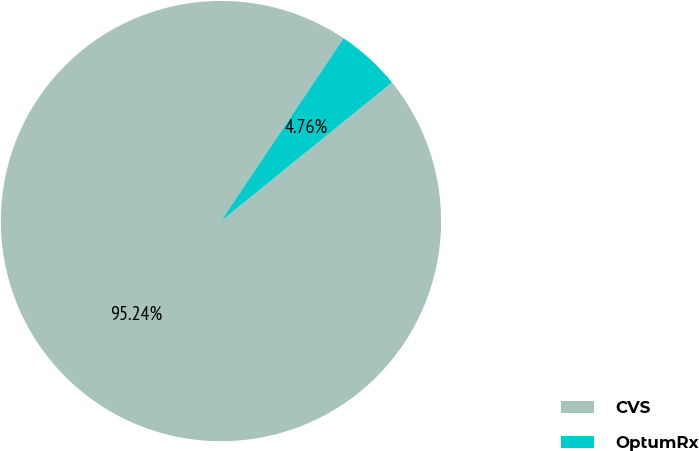Convert chart. <chart><loc_0><loc_0><loc_500><loc_500><pie_chart><fcel>CVS<fcel>OptumRx<nl><fcel>95.24%<fcel>4.76%<nl></chart> 